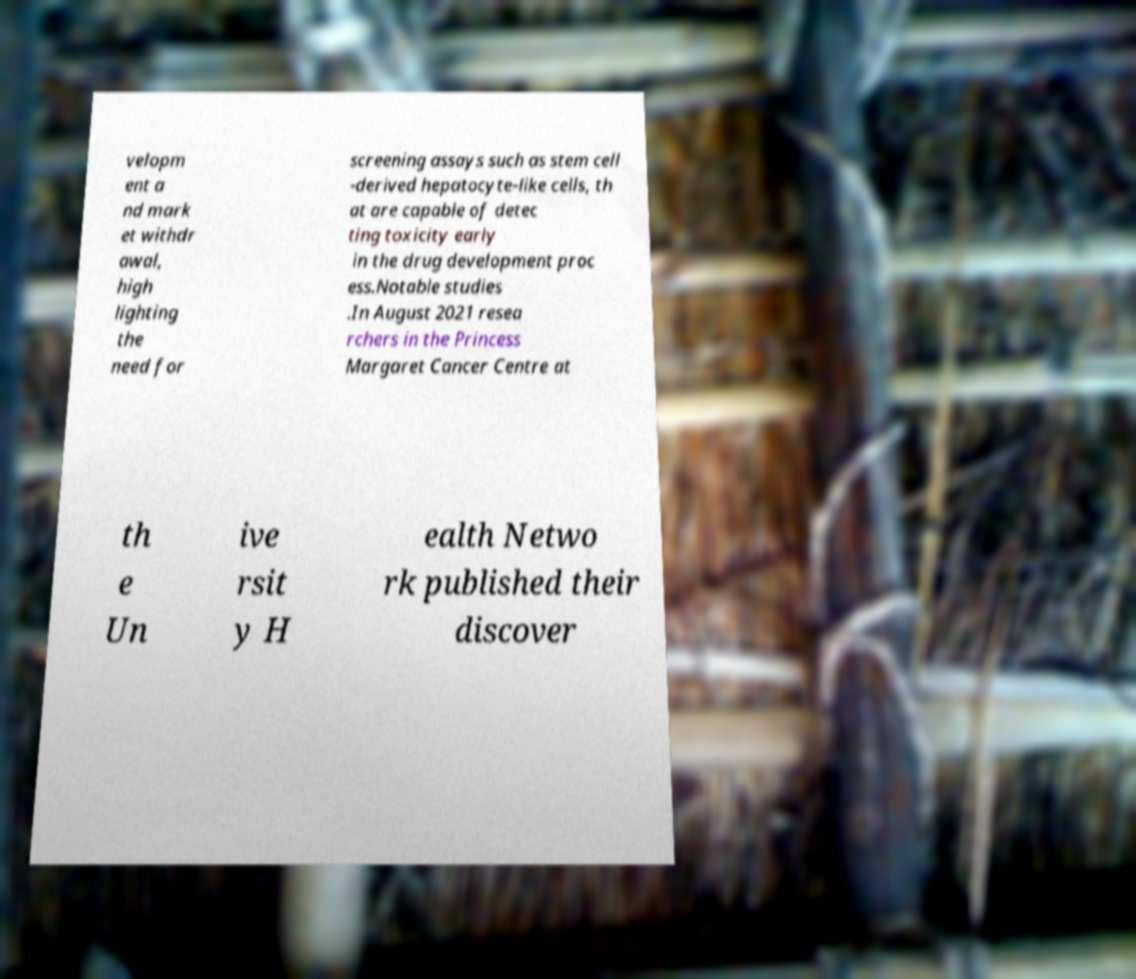What messages or text are displayed in this image? I need them in a readable, typed format. velopm ent a nd mark et withdr awal, high lighting the need for screening assays such as stem cell -derived hepatocyte-like cells, th at are capable of detec ting toxicity early in the drug development proc ess.Notable studies .In August 2021 resea rchers in the Princess Margaret Cancer Centre at th e Un ive rsit y H ealth Netwo rk published their discover 